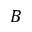Convert formula to latex. <formula><loc_0><loc_0><loc_500><loc_500>B</formula> 